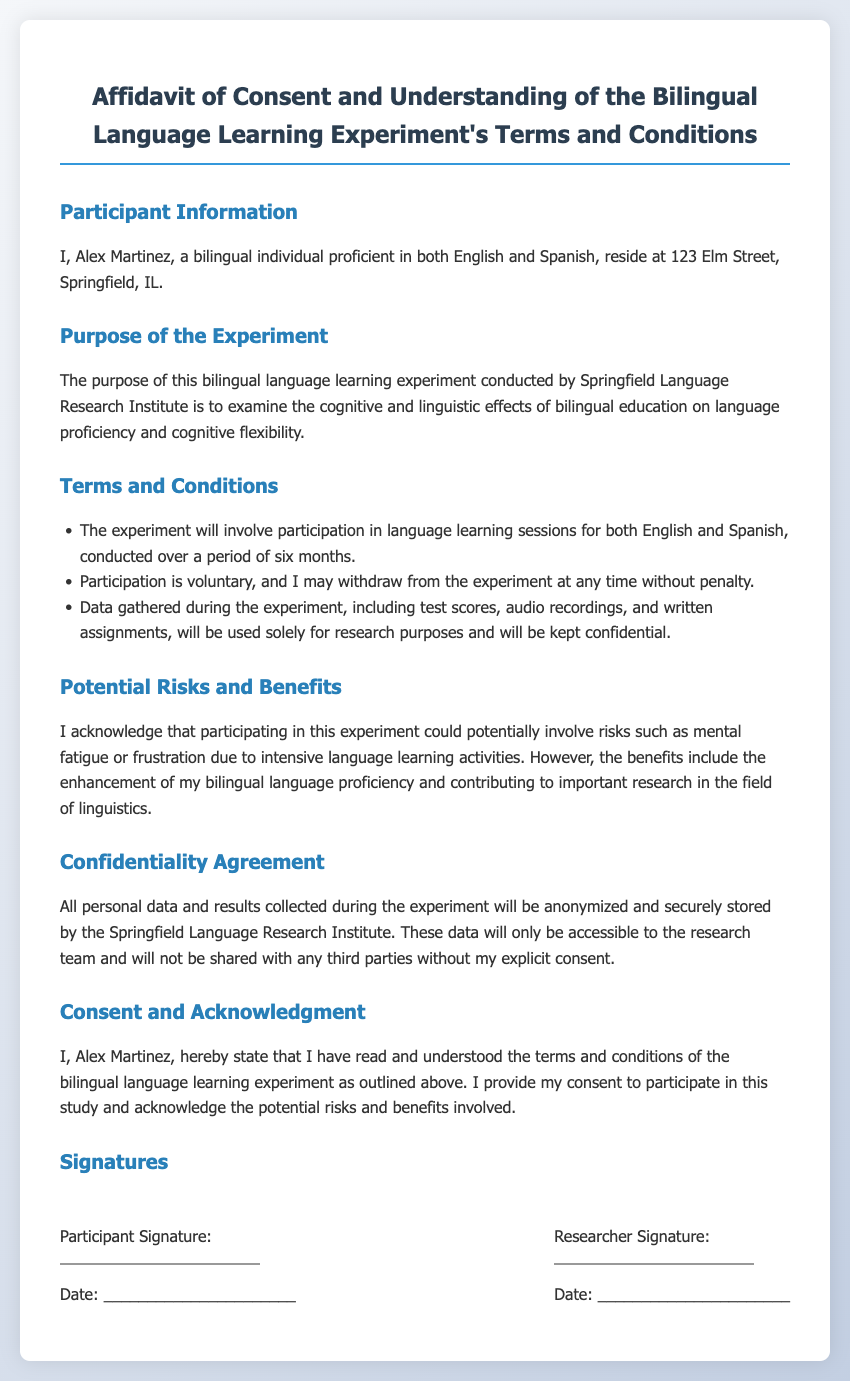What is the participant's name? The participant's name is mentioned in the document, which is Alex Martinez.
Answer: Alex Martinez What is the address of the participant? The document states the participant's residence address as 123 Elm Street, Springfield, IL.
Answer: 123 Elm Street, Springfield, IL How long will the experiment take place? The document specifies that the experiment will be conducted over a period of six months.
Answer: Six months Is participation in the experiment voluntary? The document outlines that participation is voluntary and can be withdrawn at any time.
Answer: Yes What organization is conducting the experiment? The document names the organization conducting the experiment as the Springfield Language Research Institute.
Answer: Springfield Language Research Institute What are the potential risks mentioned? The affidavit outlines risks such as mental fatigue or frustration due to intensive language learning activities.
Answer: Mental fatigue or frustration What type of data will be collected during the experiment? The document specifies that data includes test scores, audio recordings, and written assignments.
Answer: Test scores, audio recordings, and written assignments Who will have access to the collected data? The document states that the collected data will only be accessible to the research team.
Answer: Research team What is the purpose of the experiment? The purpose is outlined as examining the cognitive and linguistic effects of bilingual education.
Answer: Examining cognitive and linguistic effects 